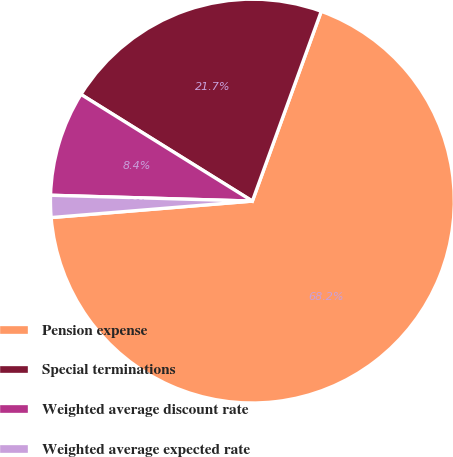Convert chart. <chart><loc_0><loc_0><loc_500><loc_500><pie_chart><fcel>Pension expense<fcel>Special terminations<fcel>Weighted average discount rate<fcel>Weighted average expected rate<nl><fcel>68.16%<fcel>21.68%<fcel>8.4%<fcel>1.76%<nl></chart> 